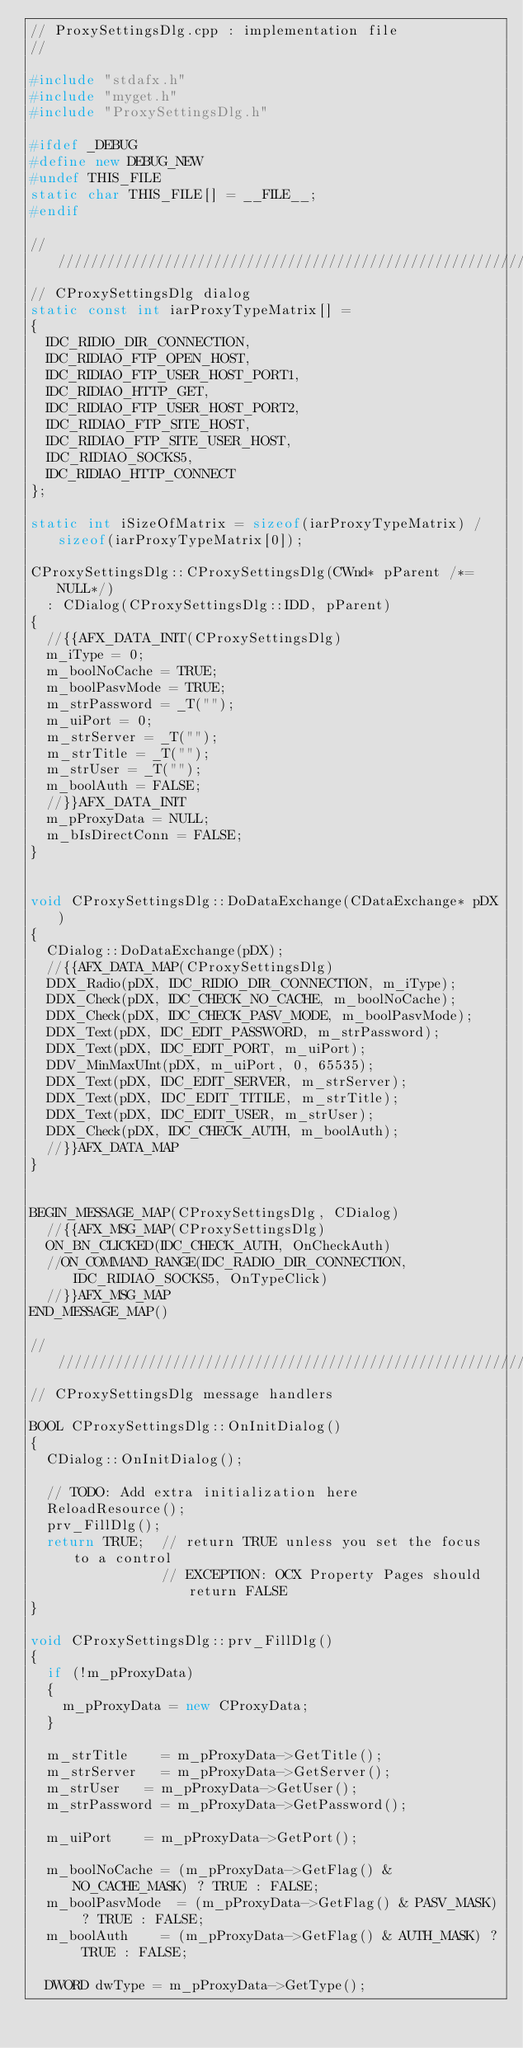<code> <loc_0><loc_0><loc_500><loc_500><_C++_>// ProxySettingsDlg.cpp : implementation file
//

#include "stdafx.h"
#include "myget.h"
#include "ProxySettingsDlg.h"

#ifdef _DEBUG
#define new DEBUG_NEW
#undef THIS_FILE
static char THIS_FILE[] = __FILE__;
#endif

/////////////////////////////////////////////////////////////////////////////
// CProxySettingsDlg dialog
static const int iarProxyTypeMatrix[] =
{
	IDC_RIDIO_DIR_CONNECTION,
	IDC_RIDIAO_FTP_OPEN_HOST,
	IDC_RIDIAO_FTP_USER_HOST_PORT1,
	IDC_RIDIAO_HTTP_GET,
	IDC_RIDIAO_FTP_USER_HOST_PORT2,
	IDC_RIDIAO_FTP_SITE_HOST,
	IDC_RIDIAO_FTP_SITE_USER_HOST,
	IDC_RIDIAO_SOCKS5,
	IDC_RIDIAO_HTTP_CONNECT
};

static int iSizeOfMatrix = sizeof(iarProxyTypeMatrix) / sizeof(iarProxyTypeMatrix[0]);

CProxySettingsDlg::CProxySettingsDlg(CWnd* pParent /*=NULL*/)
	: CDialog(CProxySettingsDlg::IDD, pParent)
{
	//{{AFX_DATA_INIT(CProxySettingsDlg)
	m_iType = 0;
	m_boolNoCache = TRUE;
	m_boolPasvMode = TRUE;
	m_strPassword = _T("");
	m_uiPort = 0;
	m_strServer = _T("");
	m_strTitle = _T("");
	m_strUser = _T("");
	m_boolAuth = FALSE;
	//}}AFX_DATA_INIT
	m_pProxyData = NULL;
	m_bIsDirectConn = FALSE;
}


void CProxySettingsDlg::DoDataExchange(CDataExchange* pDX)
{
	CDialog::DoDataExchange(pDX);
	//{{AFX_DATA_MAP(CProxySettingsDlg)
	DDX_Radio(pDX, IDC_RIDIO_DIR_CONNECTION, m_iType);
	DDX_Check(pDX, IDC_CHECK_NO_CACHE, m_boolNoCache);
	DDX_Check(pDX, IDC_CHECK_PASV_MODE, m_boolPasvMode);
	DDX_Text(pDX, IDC_EDIT_PASSWORD, m_strPassword);
	DDX_Text(pDX, IDC_EDIT_PORT, m_uiPort);
	DDV_MinMaxUInt(pDX, m_uiPort, 0, 65535);
	DDX_Text(pDX, IDC_EDIT_SERVER, m_strServer);
	DDX_Text(pDX, IDC_EDIT_TITILE, m_strTitle);
	DDX_Text(pDX, IDC_EDIT_USER, m_strUser);
	DDX_Check(pDX, IDC_CHECK_AUTH, m_boolAuth);
	//}}AFX_DATA_MAP
}


BEGIN_MESSAGE_MAP(CProxySettingsDlg, CDialog)
	//{{AFX_MSG_MAP(CProxySettingsDlg)
	ON_BN_CLICKED(IDC_CHECK_AUTH, OnCheckAuth)
	//ON_COMMAND_RANGE(IDC_RADIO_DIR_CONNECTION, IDC_RIDIAO_SOCKS5, OnTypeClick)
	//}}AFX_MSG_MAP
END_MESSAGE_MAP()

/////////////////////////////////////////////////////////////////////////////
// CProxySettingsDlg message handlers

BOOL CProxySettingsDlg::OnInitDialog() 
{
	CDialog::OnInitDialog();
	
	// TODO: Add extra initialization here
	ReloadResource();
	prv_FillDlg();
	return TRUE;  // return TRUE unless you set the focus to a control
	              // EXCEPTION: OCX Property Pages should return FALSE
}

void CProxySettingsDlg::prv_FillDlg()
{
	if (!m_pProxyData)
	{
		m_pProxyData = new CProxyData;
	}

	m_strTitle		= m_pProxyData->GetTitle();
	m_strServer		= m_pProxyData->GetServer();
	m_strUser		= m_pProxyData->GetUser();
	m_strPassword	= m_pProxyData->GetPassword();
	
	m_uiPort		= m_pProxyData->GetPort();
	
	m_boolNoCache	= (m_pProxyData->GetFlag() & NO_CACHE_MASK) ? TRUE : FALSE;
	m_boolPasvMode	= (m_pProxyData->GetFlag() & PASV_MASK) ? TRUE : FALSE;
	m_boolAuth		= (m_pProxyData->GetFlag() & AUTH_MASK) ? TRUE : FALSE;
	
	DWORD dwType = m_pProxyData->GetType();</code> 